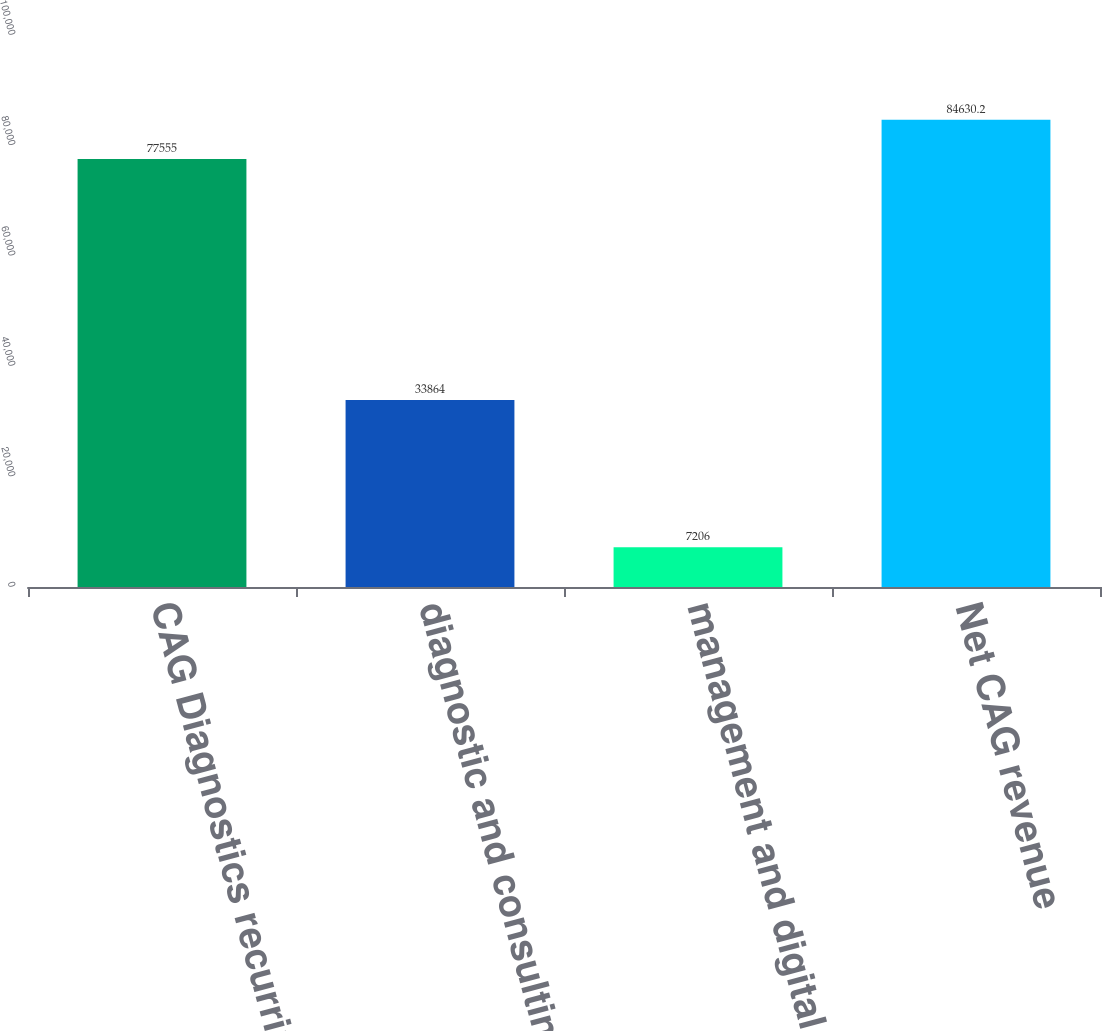Convert chart. <chart><loc_0><loc_0><loc_500><loc_500><bar_chart><fcel>CAG Diagnostics recurring<fcel>diagnostic and consulting<fcel>management and digital imaging<fcel>Net CAG revenue<nl><fcel>77555<fcel>33864<fcel>7206<fcel>84630.2<nl></chart> 